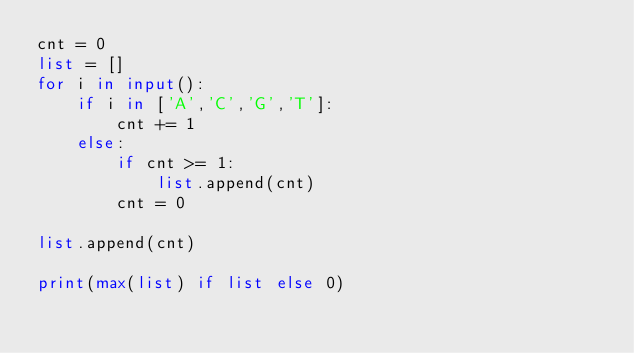Convert code to text. <code><loc_0><loc_0><loc_500><loc_500><_Python_>cnt = 0
list = []
for i in input():
    if i in ['A','C','G','T']:
        cnt += 1
    else:
        if cnt >= 1:
            list.append(cnt)
        cnt = 0

list.append(cnt)

print(max(list) if list else 0)</code> 